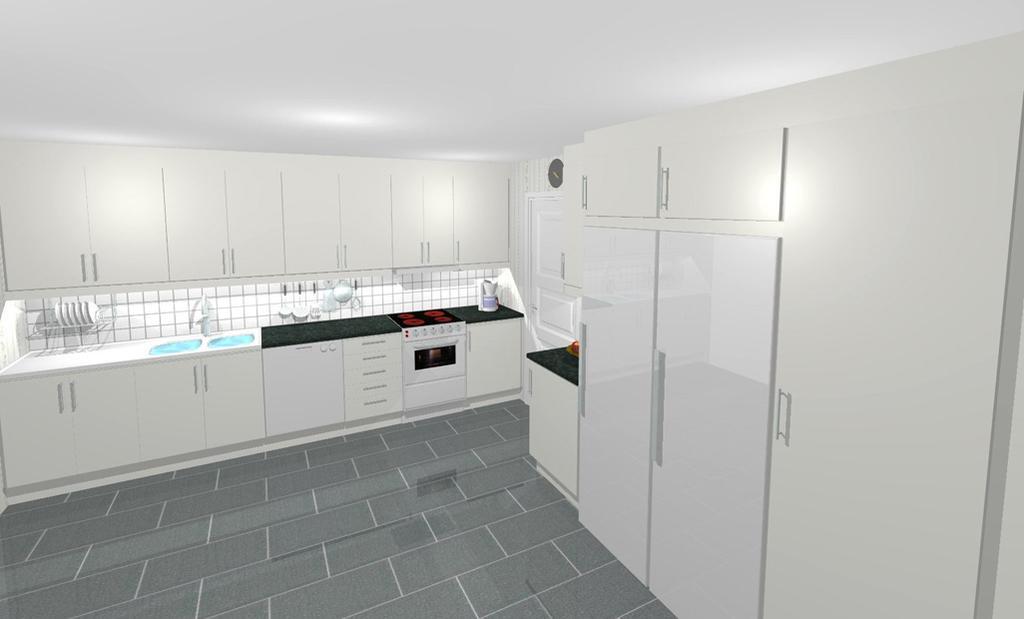In one or two sentences, can you explain what this image depicts? In this image I can see few plates, stove, an oven on the counter top. At back I can see cupboards and wall in white color. 